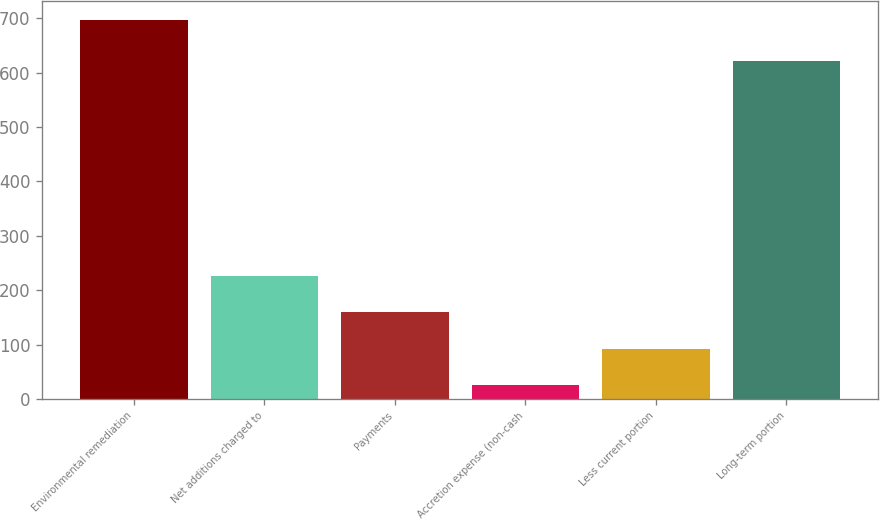<chart> <loc_0><loc_0><loc_500><loc_500><bar_chart><fcel>Environmental remediation<fcel>Net additions charged to<fcel>Payments<fcel>Accretion expense (non-cash<fcel>Less current portion<fcel>Long-term portion<nl><fcel>697.5<fcel>226.96<fcel>159.74<fcel>25.3<fcel>92.52<fcel>621.1<nl></chart> 